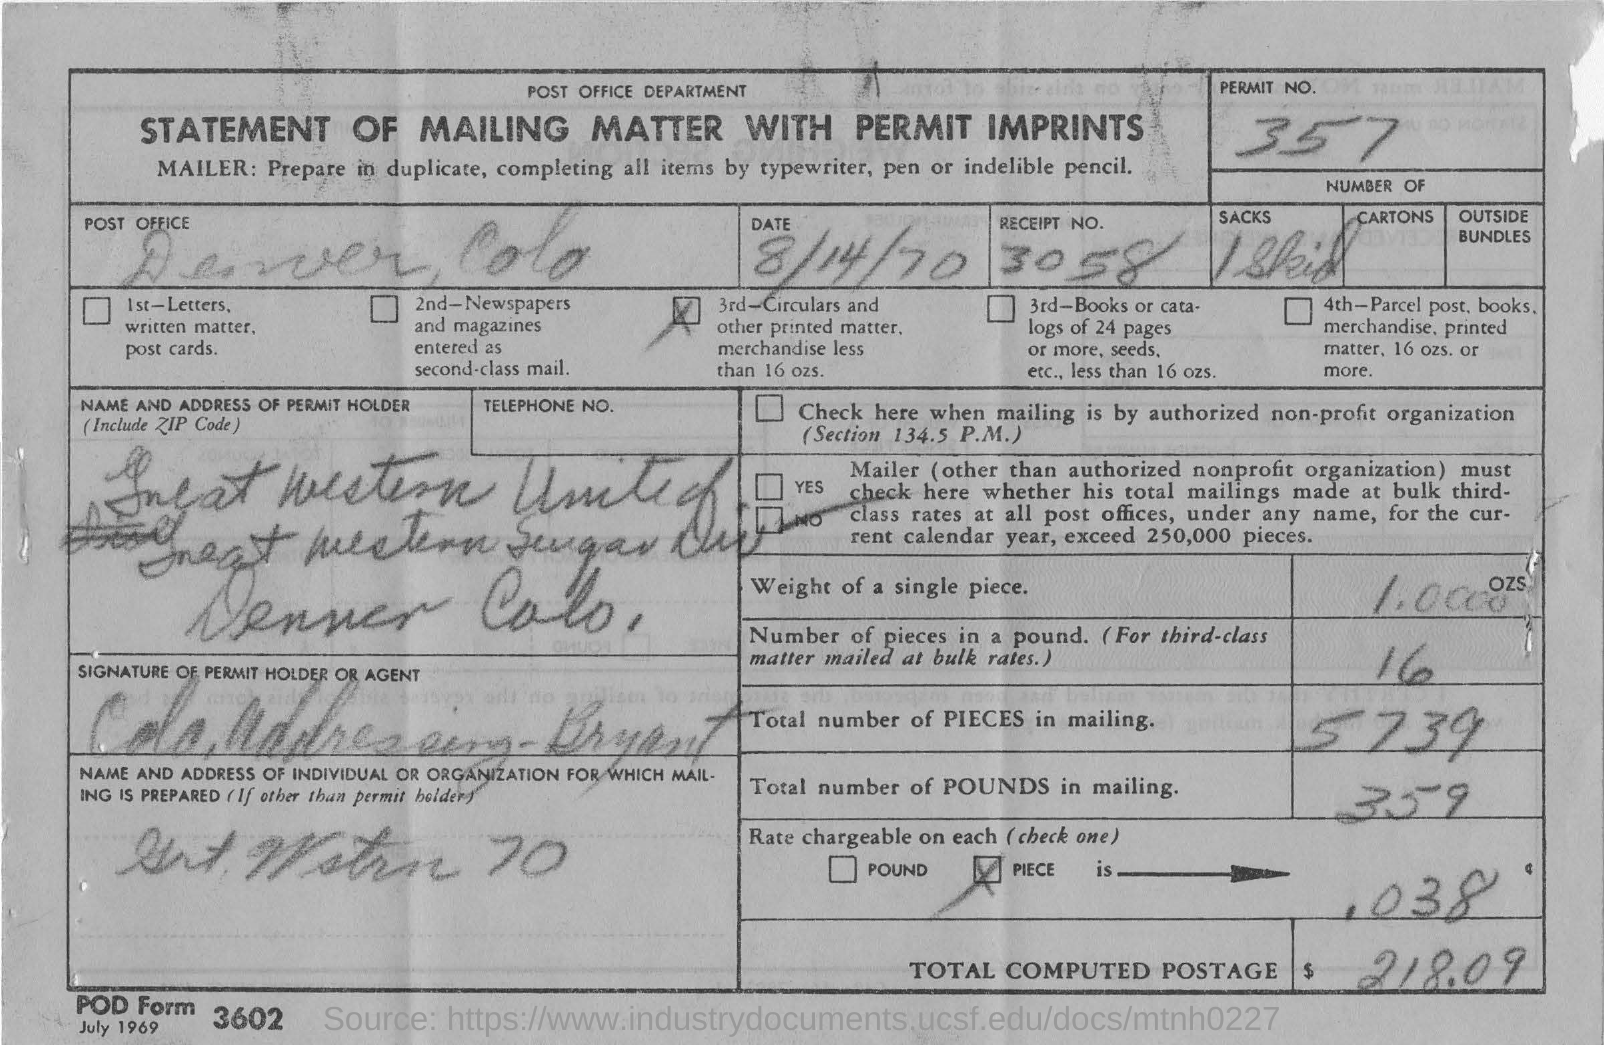Identify some key points in this picture. The total number of pieces in the mailing is 5,739. The total amount of computed postage is $218.09. The permit number is 357... The receipt number is 3058. The document is titled "Statement of Mailing Matter with Permit Imprints. 